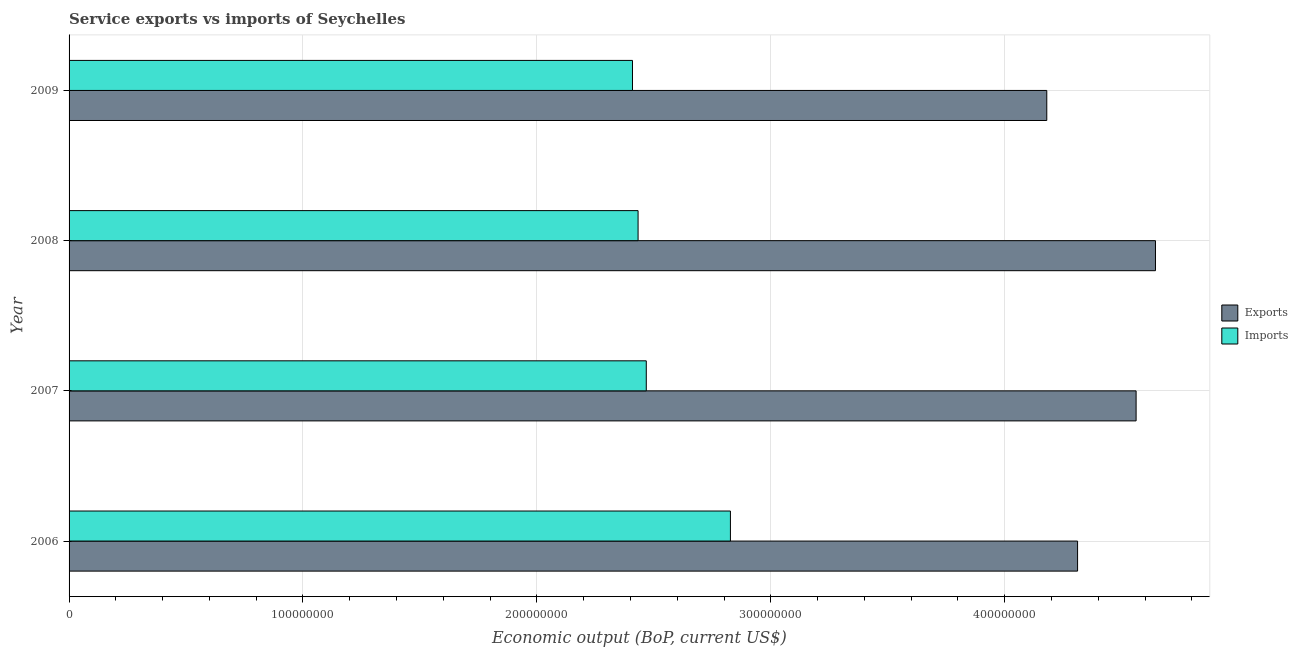How many groups of bars are there?
Offer a terse response. 4. Are the number of bars per tick equal to the number of legend labels?
Offer a very short reply. Yes. How many bars are there on the 1st tick from the bottom?
Provide a succinct answer. 2. In how many cases, is the number of bars for a given year not equal to the number of legend labels?
Your response must be concise. 0. What is the amount of service imports in 2006?
Provide a succinct answer. 2.83e+08. Across all years, what is the maximum amount of service exports?
Offer a very short reply. 4.64e+08. Across all years, what is the minimum amount of service imports?
Your answer should be very brief. 2.41e+08. In which year was the amount of service exports minimum?
Your answer should be compact. 2009. What is the total amount of service exports in the graph?
Provide a short and direct response. 1.77e+09. What is the difference between the amount of service exports in 2006 and that in 2008?
Provide a short and direct response. -3.33e+07. What is the difference between the amount of service imports in 2009 and the amount of service exports in 2007?
Your answer should be very brief. -2.15e+08. What is the average amount of service exports per year?
Your response must be concise. 4.42e+08. In the year 2009, what is the difference between the amount of service exports and amount of service imports?
Ensure brevity in your answer.  1.77e+08. What is the ratio of the amount of service imports in 2008 to that in 2009?
Make the answer very short. 1.01. What is the difference between the highest and the second highest amount of service imports?
Your answer should be very brief. 3.60e+07. What is the difference between the highest and the lowest amount of service exports?
Give a very brief answer. 4.65e+07. What does the 1st bar from the top in 2006 represents?
Offer a very short reply. Imports. What does the 2nd bar from the bottom in 2009 represents?
Ensure brevity in your answer.  Imports. Does the graph contain any zero values?
Your answer should be compact. No. Where does the legend appear in the graph?
Make the answer very short. Center right. How are the legend labels stacked?
Keep it short and to the point. Vertical. What is the title of the graph?
Offer a terse response. Service exports vs imports of Seychelles. Does "Forest land" appear as one of the legend labels in the graph?
Offer a very short reply. No. What is the label or title of the X-axis?
Keep it short and to the point. Economic output (BoP, current US$). What is the Economic output (BoP, current US$) of Exports in 2006?
Provide a short and direct response. 4.31e+08. What is the Economic output (BoP, current US$) in Imports in 2006?
Provide a short and direct response. 2.83e+08. What is the Economic output (BoP, current US$) of Exports in 2007?
Ensure brevity in your answer.  4.56e+08. What is the Economic output (BoP, current US$) of Imports in 2007?
Make the answer very short. 2.47e+08. What is the Economic output (BoP, current US$) of Exports in 2008?
Offer a terse response. 4.64e+08. What is the Economic output (BoP, current US$) in Imports in 2008?
Ensure brevity in your answer.  2.43e+08. What is the Economic output (BoP, current US$) in Exports in 2009?
Provide a succinct answer. 4.18e+08. What is the Economic output (BoP, current US$) of Imports in 2009?
Make the answer very short. 2.41e+08. Across all years, what is the maximum Economic output (BoP, current US$) in Exports?
Give a very brief answer. 4.64e+08. Across all years, what is the maximum Economic output (BoP, current US$) of Imports?
Ensure brevity in your answer.  2.83e+08. Across all years, what is the minimum Economic output (BoP, current US$) of Exports?
Offer a very short reply. 4.18e+08. Across all years, what is the minimum Economic output (BoP, current US$) in Imports?
Your answer should be compact. 2.41e+08. What is the total Economic output (BoP, current US$) in Exports in the graph?
Keep it short and to the point. 1.77e+09. What is the total Economic output (BoP, current US$) of Imports in the graph?
Provide a short and direct response. 1.01e+09. What is the difference between the Economic output (BoP, current US$) of Exports in 2006 and that in 2007?
Offer a very short reply. -2.50e+07. What is the difference between the Economic output (BoP, current US$) in Imports in 2006 and that in 2007?
Keep it short and to the point. 3.60e+07. What is the difference between the Economic output (BoP, current US$) of Exports in 2006 and that in 2008?
Ensure brevity in your answer.  -3.33e+07. What is the difference between the Economic output (BoP, current US$) of Imports in 2006 and that in 2008?
Offer a terse response. 3.95e+07. What is the difference between the Economic output (BoP, current US$) of Exports in 2006 and that in 2009?
Your response must be concise. 1.32e+07. What is the difference between the Economic output (BoP, current US$) in Imports in 2006 and that in 2009?
Your answer should be compact. 4.19e+07. What is the difference between the Economic output (BoP, current US$) of Exports in 2007 and that in 2008?
Provide a short and direct response. -8.28e+06. What is the difference between the Economic output (BoP, current US$) in Imports in 2007 and that in 2008?
Offer a terse response. 3.50e+06. What is the difference between the Economic output (BoP, current US$) in Exports in 2007 and that in 2009?
Provide a succinct answer. 3.82e+07. What is the difference between the Economic output (BoP, current US$) of Imports in 2007 and that in 2009?
Your response must be concise. 5.90e+06. What is the difference between the Economic output (BoP, current US$) in Exports in 2008 and that in 2009?
Provide a succinct answer. 4.65e+07. What is the difference between the Economic output (BoP, current US$) of Imports in 2008 and that in 2009?
Offer a terse response. 2.39e+06. What is the difference between the Economic output (BoP, current US$) of Exports in 2006 and the Economic output (BoP, current US$) of Imports in 2007?
Offer a terse response. 1.84e+08. What is the difference between the Economic output (BoP, current US$) in Exports in 2006 and the Economic output (BoP, current US$) in Imports in 2008?
Your answer should be very brief. 1.88e+08. What is the difference between the Economic output (BoP, current US$) in Exports in 2006 and the Economic output (BoP, current US$) in Imports in 2009?
Offer a very short reply. 1.90e+08. What is the difference between the Economic output (BoP, current US$) in Exports in 2007 and the Economic output (BoP, current US$) in Imports in 2008?
Make the answer very short. 2.13e+08. What is the difference between the Economic output (BoP, current US$) in Exports in 2007 and the Economic output (BoP, current US$) in Imports in 2009?
Provide a succinct answer. 2.15e+08. What is the difference between the Economic output (BoP, current US$) in Exports in 2008 and the Economic output (BoP, current US$) in Imports in 2009?
Your response must be concise. 2.24e+08. What is the average Economic output (BoP, current US$) of Exports per year?
Make the answer very short. 4.42e+08. What is the average Economic output (BoP, current US$) of Imports per year?
Your response must be concise. 2.53e+08. In the year 2006, what is the difference between the Economic output (BoP, current US$) of Exports and Economic output (BoP, current US$) of Imports?
Offer a very short reply. 1.48e+08. In the year 2007, what is the difference between the Economic output (BoP, current US$) of Exports and Economic output (BoP, current US$) of Imports?
Offer a terse response. 2.09e+08. In the year 2008, what is the difference between the Economic output (BoP, current US$) of Exports and Economic output (BoP, current US$) of Imports?
Provide a succinct answer. 2.21e+08. In the year 2009, what is the difference between the Economic output (BoP, current US$) of Exports and Economic output (BoP, current US$) of Imports?
Offer a very short reply. 1.77e+08. What is the ratio of the Economic output (BoP, current US$) in Exports in 2006 to that in 2007?
Offer a very short reply. 0.95. What is the ratio of the Economic output (BoP, current US$) of Imports in 2006 to that in 2007?
Offer a terse response. 1.15. What is the ratio of the Economic output (BoP, current US$) in Exports in 2006 to that in 2008?
Keep it short and to the point. 0.93. What is the ratio of the Economic output (BoP, current US$) of Imports in 2006 to that in 2008?
Offer a very short reply. 1.16. What is the ratio of the Economic output (BoP, current US$) in Exports in 2006 to that in 2009?
Your response must be concise. 1.03. What is the ratio of the Economic output (BoP, current US$) in Imports in 2006 to that in 2009?
Your answer should be compact. 1.17. What is the ratio of the Economic output (BoP, current US$) of Exports in 2007 to that in 2008?
Your answer should be compact. 0.98. What is the ratio of the Economic output (BoP, current US$) of Imports in 2007 to that in 2008?
Keep it short and to the point. 1.01. What is the ratio of the Economic output (BoP, current US$) of Exports in 2007 to that in 2009?
Ensure brevity in your answer.  1.09. What is the ratio of the Economic output (BoP, current US$) in Imports in 2007 to that in 2009?
Provide a short and direct response. 1.02. What is the ratio of the Economic output (BoP, current US$) of Exports in 2008 to that in 2009?
Make the answer very short. 1.11. What is the ratio of the Economic output (BoP, current US$) in Imports in 2008 to that in 2009?
Provide a succinct answer. 1.01. What is the difference between the highest and the second highest Economic output (BoP, current US$) in Exports?
Your response must be concise. 8.28e+06. What is the difference between the highest and the second highest Economic output (BoP, current US$) in Imports?
Offer a terse response. 3.60e+07. What is the difference between the highest and the lowest Economic output (BoP, current US$) of Exports?
Keep it short and to the point. 4.65e+07. What is the difference between the highest and the lowest Economic output (BoP, current US$) of Imports?
Your answer should be compact. 4.19e+07. 